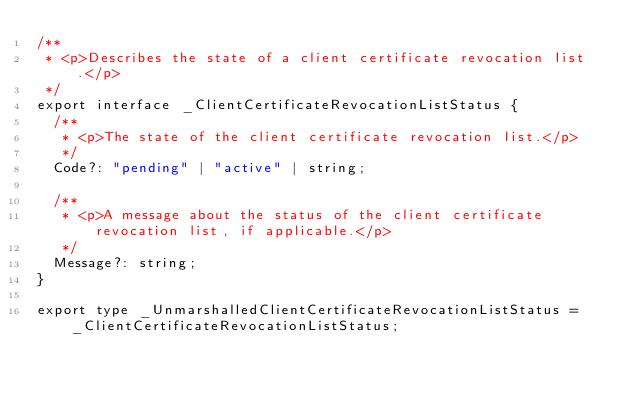<code> <loc_0><loc_0><loc_500><loc_500><_TypeScript_>/**
 * <p>Describes the state of a client certificate revocation list.</p>
 */
export interface _ClientCertificateRevocationListStatus {
  /**
   * <p>The state of the client certificate revocation list.</p>
   */
  Code?: "pending" | "active" | string;

  /**
   * <p>A message about the status of the client certificate revocation list, if applicable.</p>
   */
  Message?: string;
}

export type _UnmarshalledClientCertificateRevocationListStatus = _ClientCertificateRevocationListStatus;
</code> 